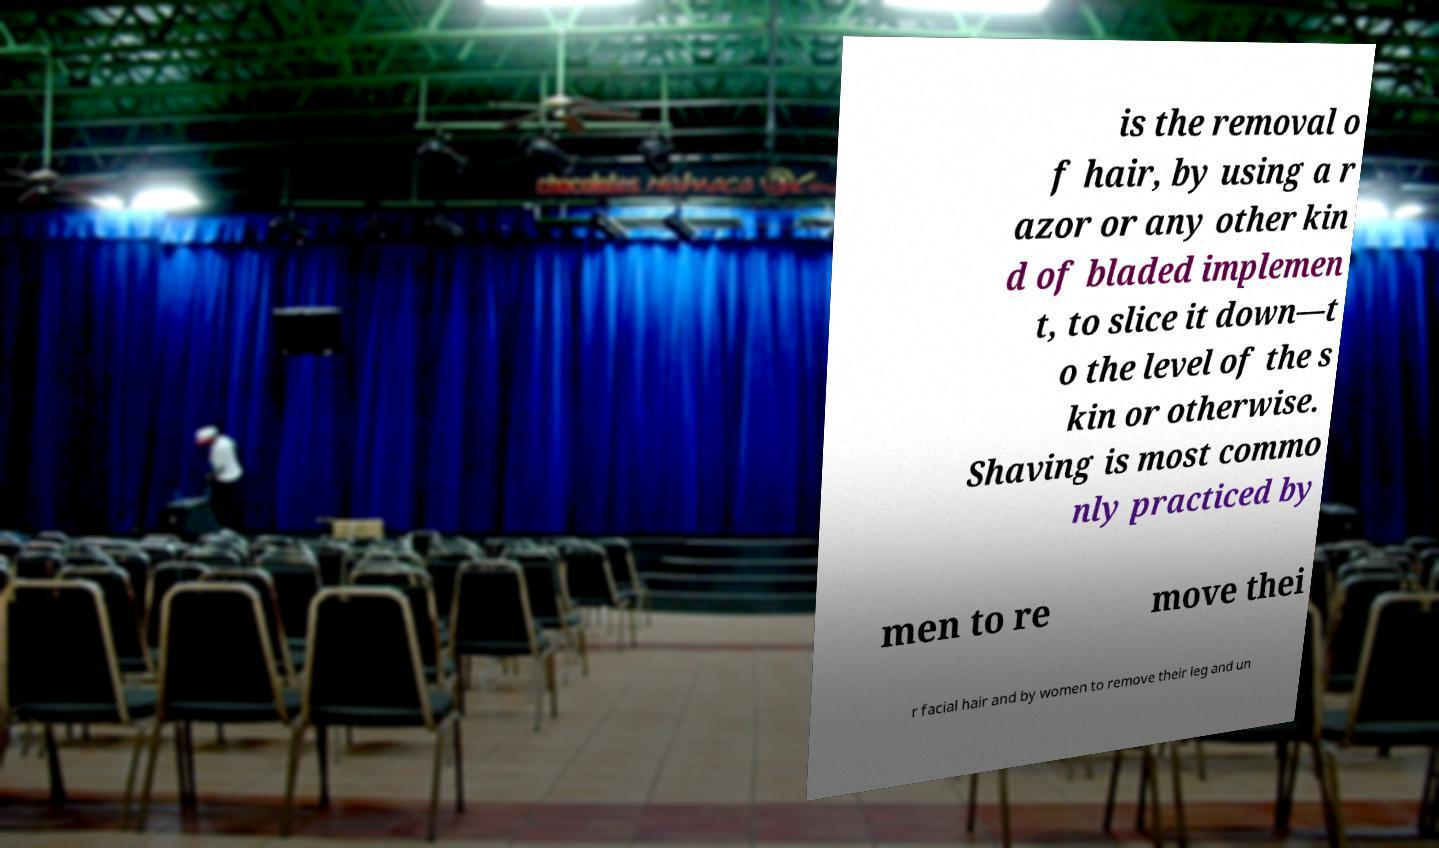Please read and relay the text visible in this image. What does it say? is the removal o f hair, by using a r azor or any other kin d of bladed implemen t, to slice it down—t o the level of the s kin or otherwise. Shaving is most commo nly practiced by men to re move thei r facial hair and by women to remove their leg and un 